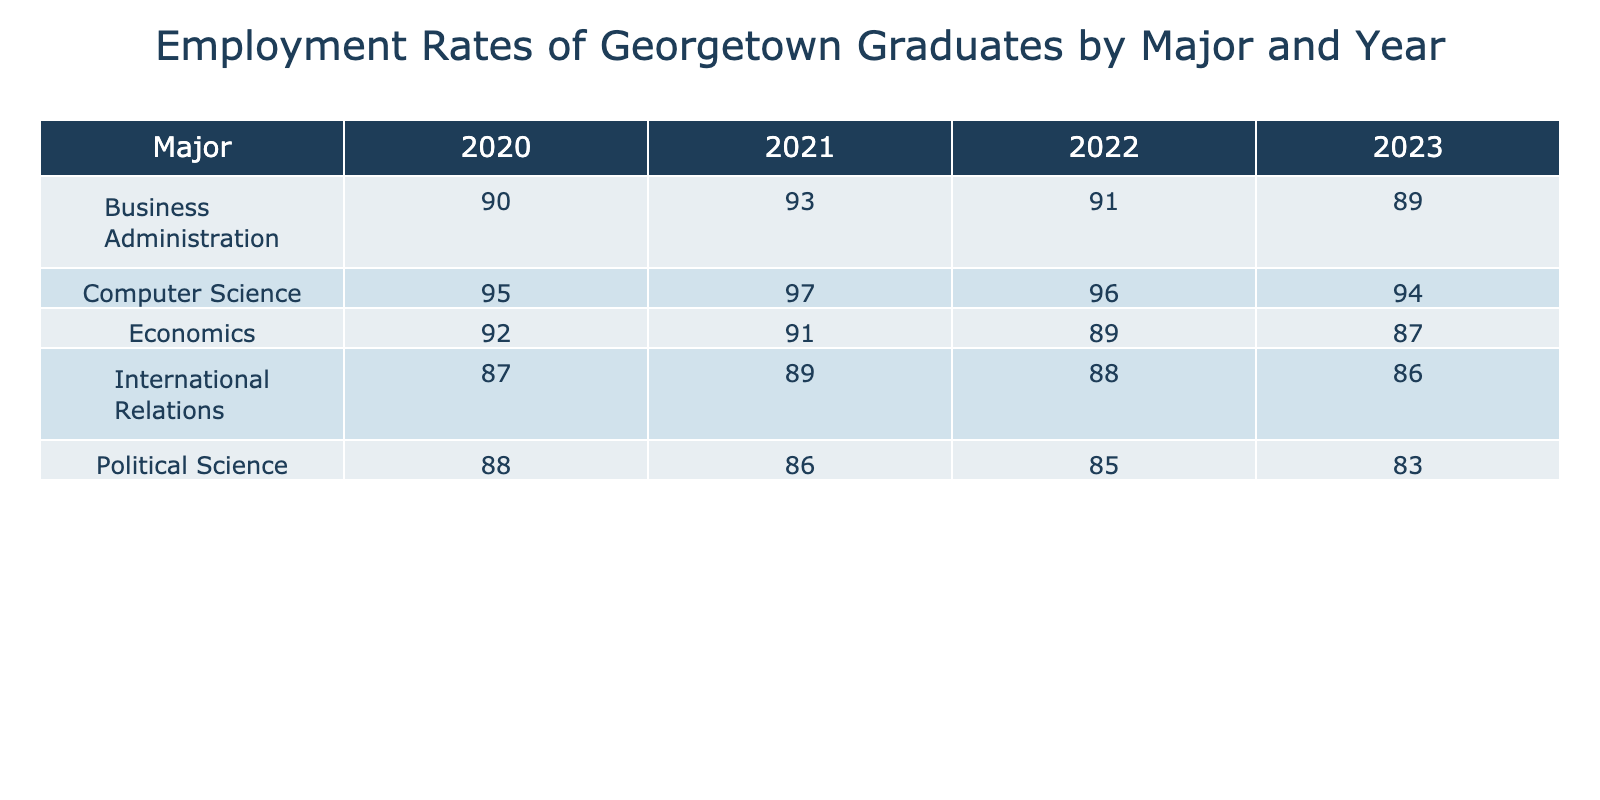What is the employment rate for Computer Science graduates in 2021? The table shows the employment rates for graduates by major and graduation year. The rate for Computer Science in the year 2021 is 97.
Answer: 97 What is the employment rate for Political Science graduates in 2022? In the table, the employment rate for the Political Science major for the year 2022 is listed as 85.
Answer: 85 Which major had the highest employment rate in 2020? The employment rates for each major in 2020 are: Economics (92), Computer Science (95), Political Science (88), Business Administration (90), and International Relations (87). Among these, Computer Science with 95 had the highest rate.
Answer: Computer Science What is the average employment rate for International Relations graduates from 2020 to 2023? For International Relations, the employment rates over the years are: 87 (2020), 89 (2021), 88 (2022), and 86 (2023). To find the average, sum these values: 87 + 89 + 88 + 86 = 350. Then divide by 4 (the number of years): 350 / 4 = 87.5.
Answer: 87.5 Is the employment rate for Economics graduates in 2022 less than 90? The table indicates that the employment rate for Economics graduates in 2022 is 89, which is indeed less than 90. Therefore, the statement is true.
Answer: Yes What is the difference between the highest and lowest employment rates for Business Administration graduates from 2020 to 2023? The employment rates for Business Administration graduates are: 90 (2020), 93 (2021), 91 (2022), and 89 (2023). The highest is 93 and the lowest is 89. To find the difference, subtract the lowest from the highest: 93 - 89 = 4.
Answer: 4 How many majors had an employment rate above 90% for the year 2023? In 2023, the employment rates are: Economics (87), Computer Science (94), Political Science (83), Business Administration (89), and International Relations (86). Only Computer Science (94) had an employment rate above 90%, giving a total of one major.
Answer: 1 Which major had the lowest employment rate across all years? Looking at the data for each year, the lowest employment rates were: Political Science (83 in 2023). This is the lowest compared to any other major across the provided years.
Answer: Political Science What is the employment rate trend for Computer Science graduates over the years provided? The employment rates for Computer Science over the years are: 95 (2020), 97 (2021), 96 (2022), and 94 (2023). The trend shows an initial increase from 2020 to 2021, then steady at 96 before a small drop in 2023 to 94. This indicates a general upward trend with a slight decline in the last year.
Answer: Initial increase, slight decline in 2023 